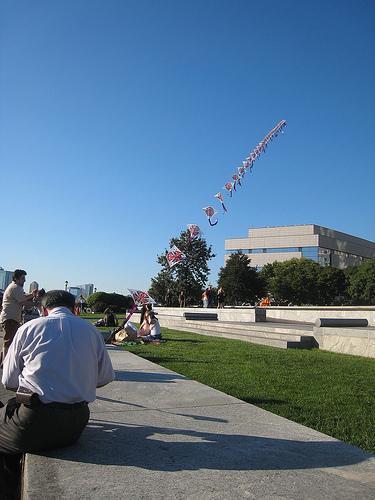How many kites are being flown?
Give a very brief answer. 1. 